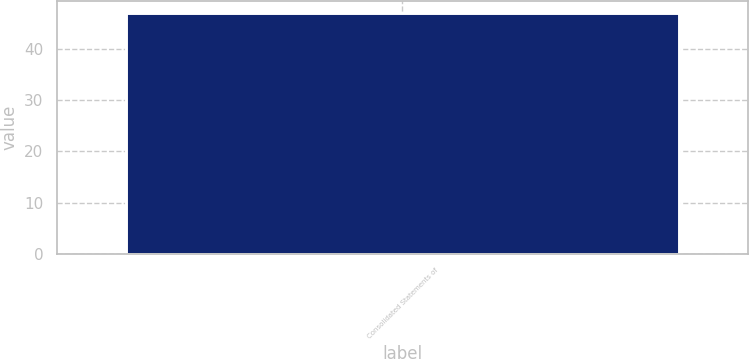Convert chart to OTSL. <chart><loc_0><loc_0><loc_500><loc_500><bar_chart><fcel>Consolidated Statements of<nl><fcel>47<nl></chart> 